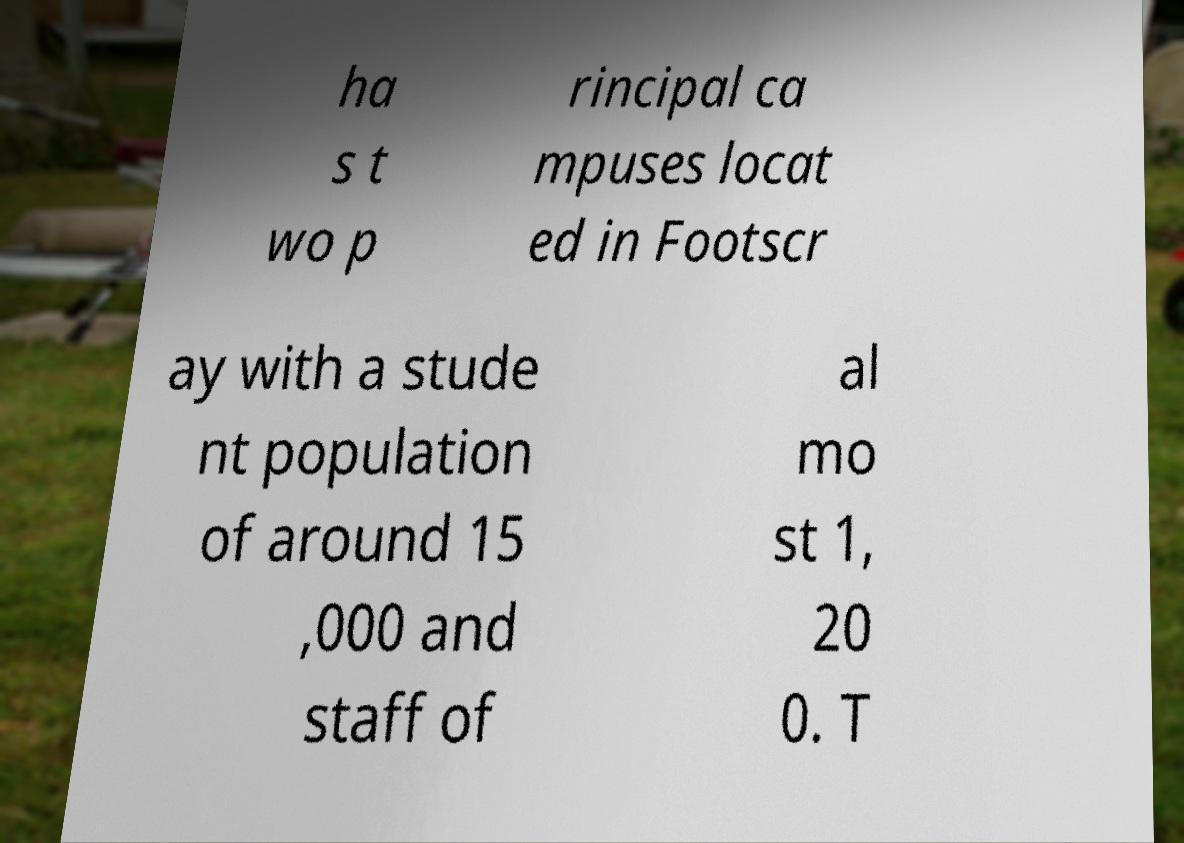Could you assist in decoding the text presented in this image and type it out clearly? ha s t wo p rincipal ca mpuses locat ed in Footscr ay with a stude nt population of around 15 ,000 and staff of al mo st 1, 20 0. T 